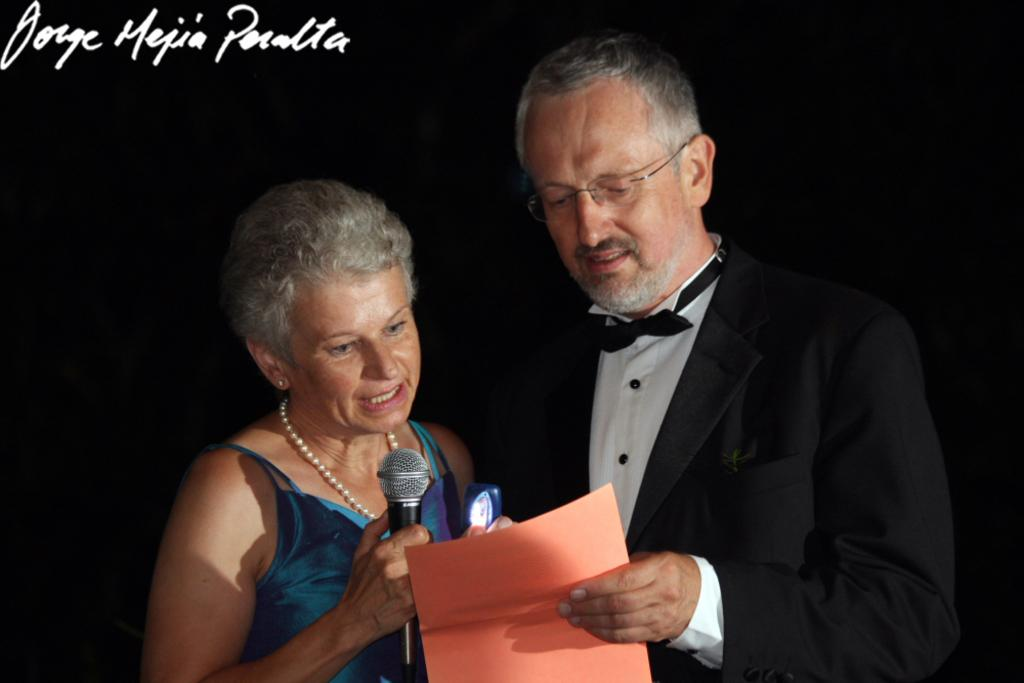How many people are present in the image? There are two people in the image. What is one person holding in the image? One person is holding a microphone. What is the other person holding in the image? The other person is holding a paper. Can you see a blade being used by one of the people in the image? No, there is no blade present in the image. How does the person holding the paper help the person with the microphone? The image does not show any interaction between the two people, so it is not possible to determine how one person might help the other. 